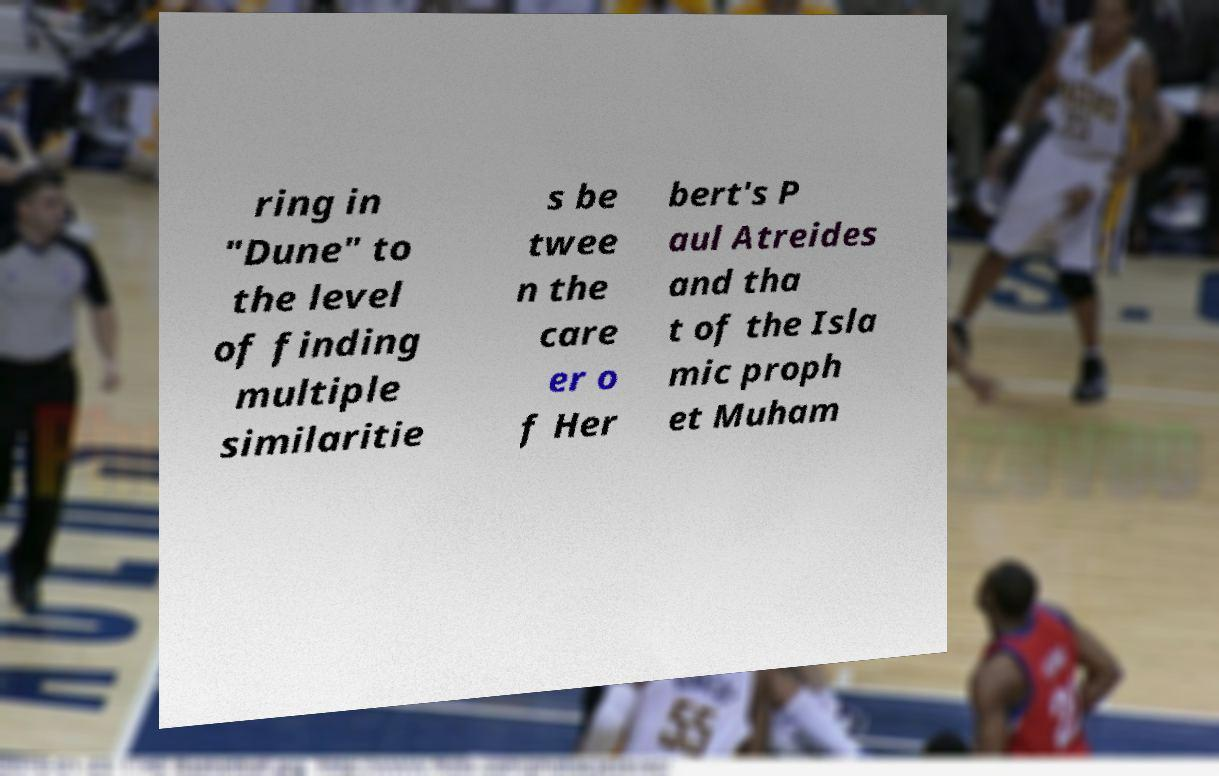Could you extract and type out the text from this image? ring in "Dune" to the level of finding multiple similaritie s be twee n the care er o f Her bert's P aul Atreides and tha t of the Isla mic proph et Muham 